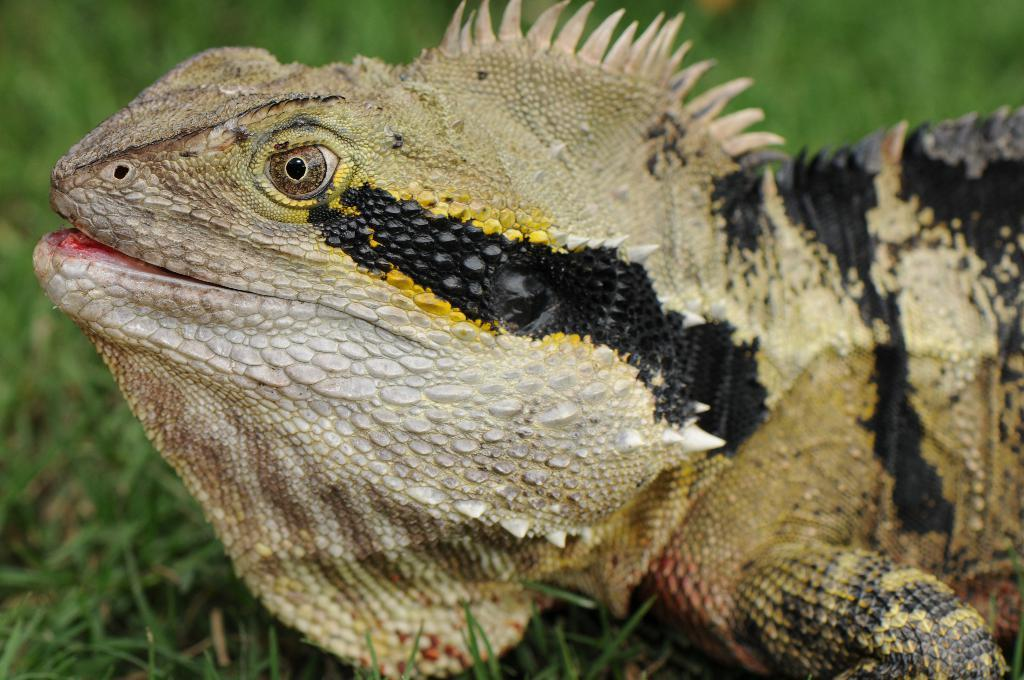What type of animal is in the image? There is a reptile in the image. Where is the reptile located? The reptile is on the grass. What type of paste is the reptile using to stick itself to the grass? There is no paste present in the image, and the reptile is not using any substance to stick itself to the grass. 